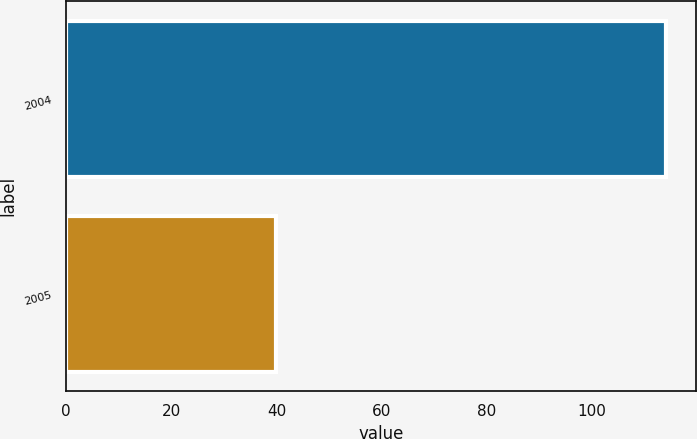Convert chart to OTSL. <chart><loc_0><loc_0><loc_500><loc_500><bar_chart><fcel>2004<fcel>2005<nl><fcel>114<fcel>40<nl></chart> 